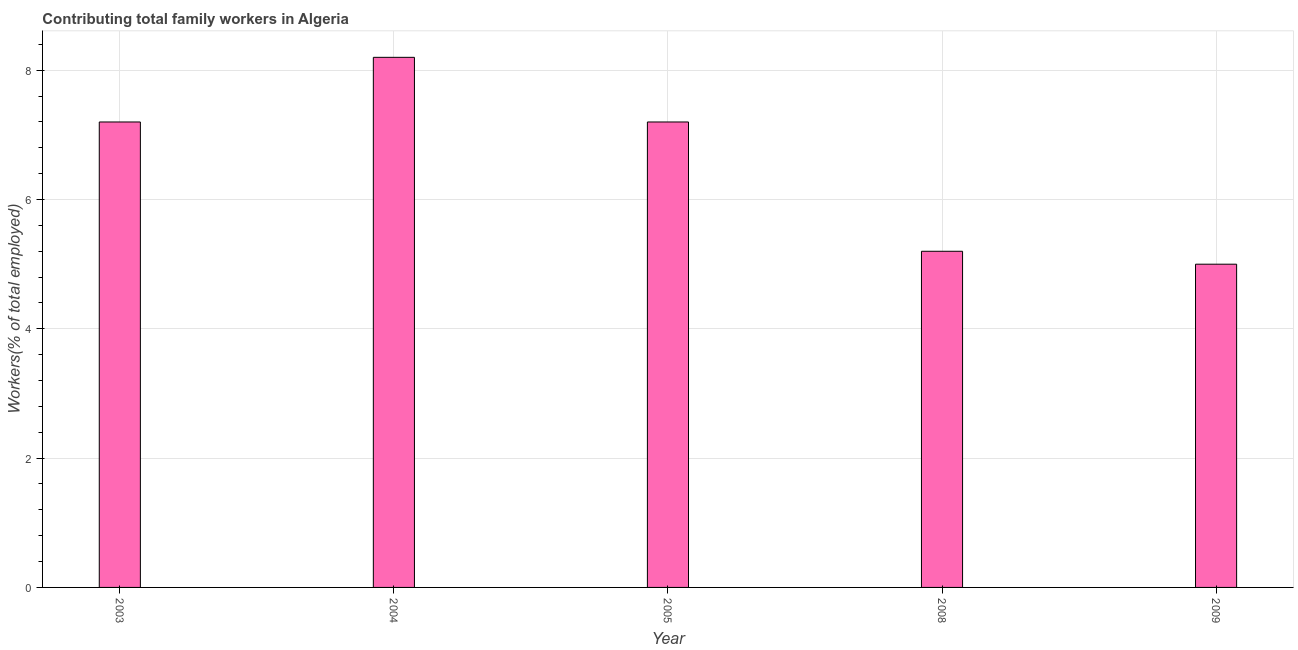What is the title of the graph?
Ensure brevity in your answer.  Contributing total family workers in Algeria. What is the label or title of the Y-axis?
Provide a succinct answer. Workers(% of total employed). What is the contributing family workers in 2008?
Provide a succinct answer. 5.2. Across all years, what is the maximum contributing family workers?
Offer a terse response. 8.2. Across all years, what is the minimum contributing family workers?
Give a very brief answer. 5. In which year was the contributing family workers maximum?
Offer a very short reply. 2004. In which year was the contributing family workers minimum?
Give a very brief answer. 2009. What is the sum of the contributing family workers?
Your answer should be very brief. 32.8. What is the difference between the contributing family workers in 2005 and 2009?
Offer a very short reply. 2.2. What is the average contributing family workers per year?
Offer a very short reply. 6.56. What is the median contributing family workers?
Give a very brief answer. 7.2. In how many years, is the contributing family workers greater than 4 %?
Offer a very short reply. 5. Do a majority of the years between 2003 and 2005 (inclusive) have contributing family workers greater than 2.4 %?
Give a very brief answer. Yes. What is the ratio of the contributing family workers in 2003 to that in 2009?
Your response must be concise. 1.44. Is the contributing family workers in 2004 less than that in 2005?
Offer a terse response. No. What is the difference between the highest and the second highest contributing family workers?
Provide a short and direct response. 1. In how many years, is the contributing family workers greater than the average contributing family workers taken over all years?
Keep it short and to the point. 3. Are all the bars in the graph horizontal?
Provide a succinct answer. No. How many years are there in the graph?
Ensure brevity in your answer.  5. What is the difference between two consecutive major ticks on the Y-axis?
Ensure brevity in your answer.  2. What is the Workers(% of total employed) of 2003?
Your answer should be very brief. 7.2. What is the Workers(% of total employed) of 2004?
Your response must be concise. 8.2. What is the Workers(% of total employed) of 2005?
Your response must be concise. 7.2. What is the Workers(% of total employed) of 2008?
Keep it short and to the point. 5.2. What is the Workers(% of total employed) of 2009?
Your response must be concise. 5. What is the difference between the Workers(% of total employed) in 2003 and 2004?
Give a very brief answer. -1. What is the difference between the Workers(% of total employed) in 2003 and 2005?
Offer a terse response. 0. What is the difference between the Workers(% of total employed) in 2003 and 2008?
Make the answer very short. 2. What is the difference between the Workers(% of total employed) in 2005 and 2008?
Give a very brief answer. 2. What is the ratio of the Workers(% of total employed) in 2003 to that in 2004?
Your response must be concise. 0.88. What is the ratio of the Workers(% of total employed) in 2003 to that in 2008?
Your answer should be very brief. 1.39. What is the ratio of the Workers(% of total employed) in 2003 to that in 2009?
Provide a short and direct response. 1.44. What is the ratio of the Workers(% of total employed) in 2004 to that in 2005?
Your answer should be compact. 1.14. What is the ratio of the Workers(% of total employed) in 2004 to that in 2008?
Your answer should be very brief. 1.58. What is the ratio of the Workers(% of total employed) in 2004 to that in 2009?
Make the answer very short. 1.64. What is the ratio of the Workers(% of total employed) in 2005 to that in 2008?
Offer a very short reply. 1.39. What is the ratio of the Workers(% of total employed) in 2005 to that in 2009?
Your answer should be very brief. 1.44. 